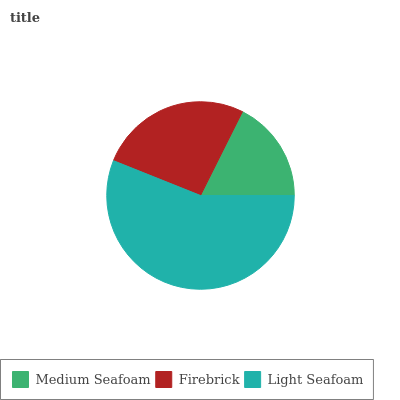Is Medium Seafoam the minimum?
Answer yes or no. Yes. Is Light Seafoam the maximum?
Answer yes or no. Yes. Is Firebrick the minimum?
Answer yes or no. No. Is Firebrick the maximum?
Answer yes or no. No. Is Firebrick greater than Medium Seafoam?
Answer yes or no. Yes. Is Medium Seafoam less than Firebrick?
Answer yes or no. Yes. Is Medium Seafoam greater than Firebrick?
Answer yes or no. No. Is Firebrick less than Medium Seafoam?
Answer yes or no. No. Is Firebrick the high median?
Answer yes or no. Yes. Is Firebrick the low median?
Answer yes or no. Yes. Is Medium Seafoam the high median?
Answer yes or no. No. Is Medium Seafoam the low median?
Answer yes or no. No. 